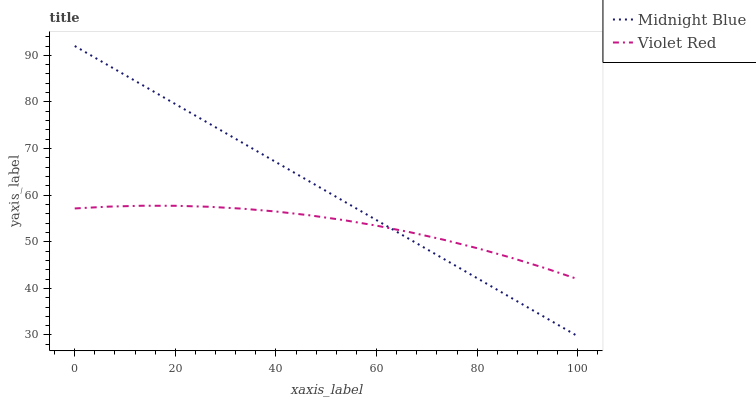Does Violet Red have the minimum area under the curve?
Answer yes or no. Yes. Does Midnight Blue have the maximum area under the curve?
Answer yes or no. Yes. Does Midnight Blue have the minimum area under the curve?
Answer yes or no. No. Is Midnight Blue the smoothest?
Answer yes or no. Yes. Is Violet Red the roughest?
Answer yes or no. Yes. Is Midnight Blue the roughest?
Answer yes or no. No. Does Midnight Blue have the lowest value?
Answer yes or no. Yes. Does Midnight Blue have the highest value?
Answer yes or no. Yes. Does Midnight Blue intersect Violet Red?
Answer yes or no. Yes. Is Midnight Blue less than Violet Red?
Answer yes or no. No. Is Midnight Blue greater than Violet Red?
Answer yes or no. No. 